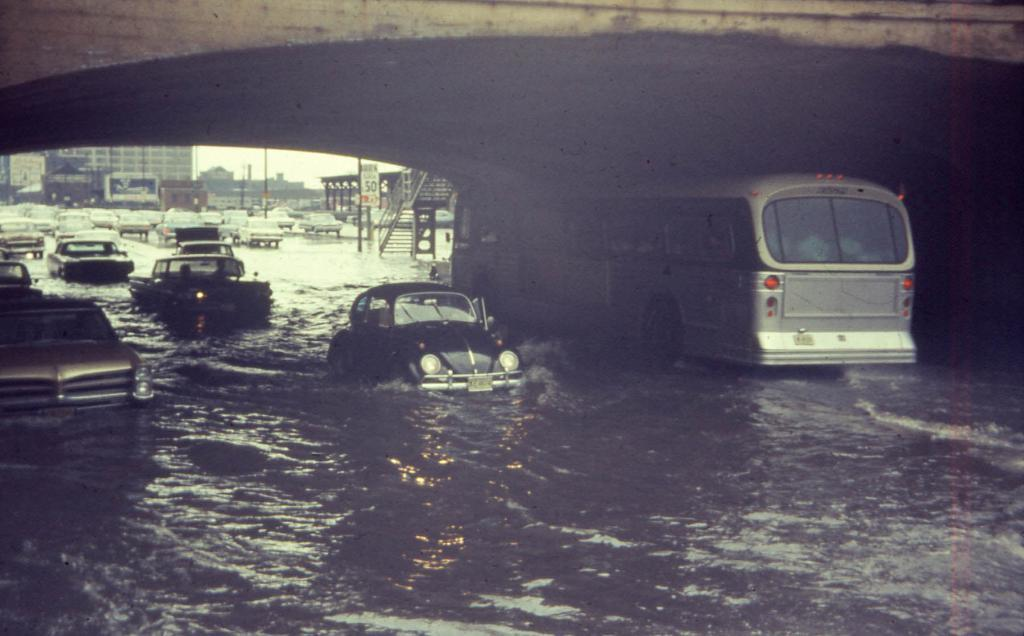What is at the bottom of the image? There is water at the bottom of the image. What types of transportation can be seen in the image? Vehicles are visible in the image. What structure is at the top of the image? There is a bridge at the top of the image. What can be seen in the distance in the image? There are buildings in the background of the image. What other objects are present in the background of the image? Poles and a board are present in the background of the image. Can you tell me how many ducks are exchanging paste on the bridge in the image? There are no ducks or any exchange of paste present in the image. 